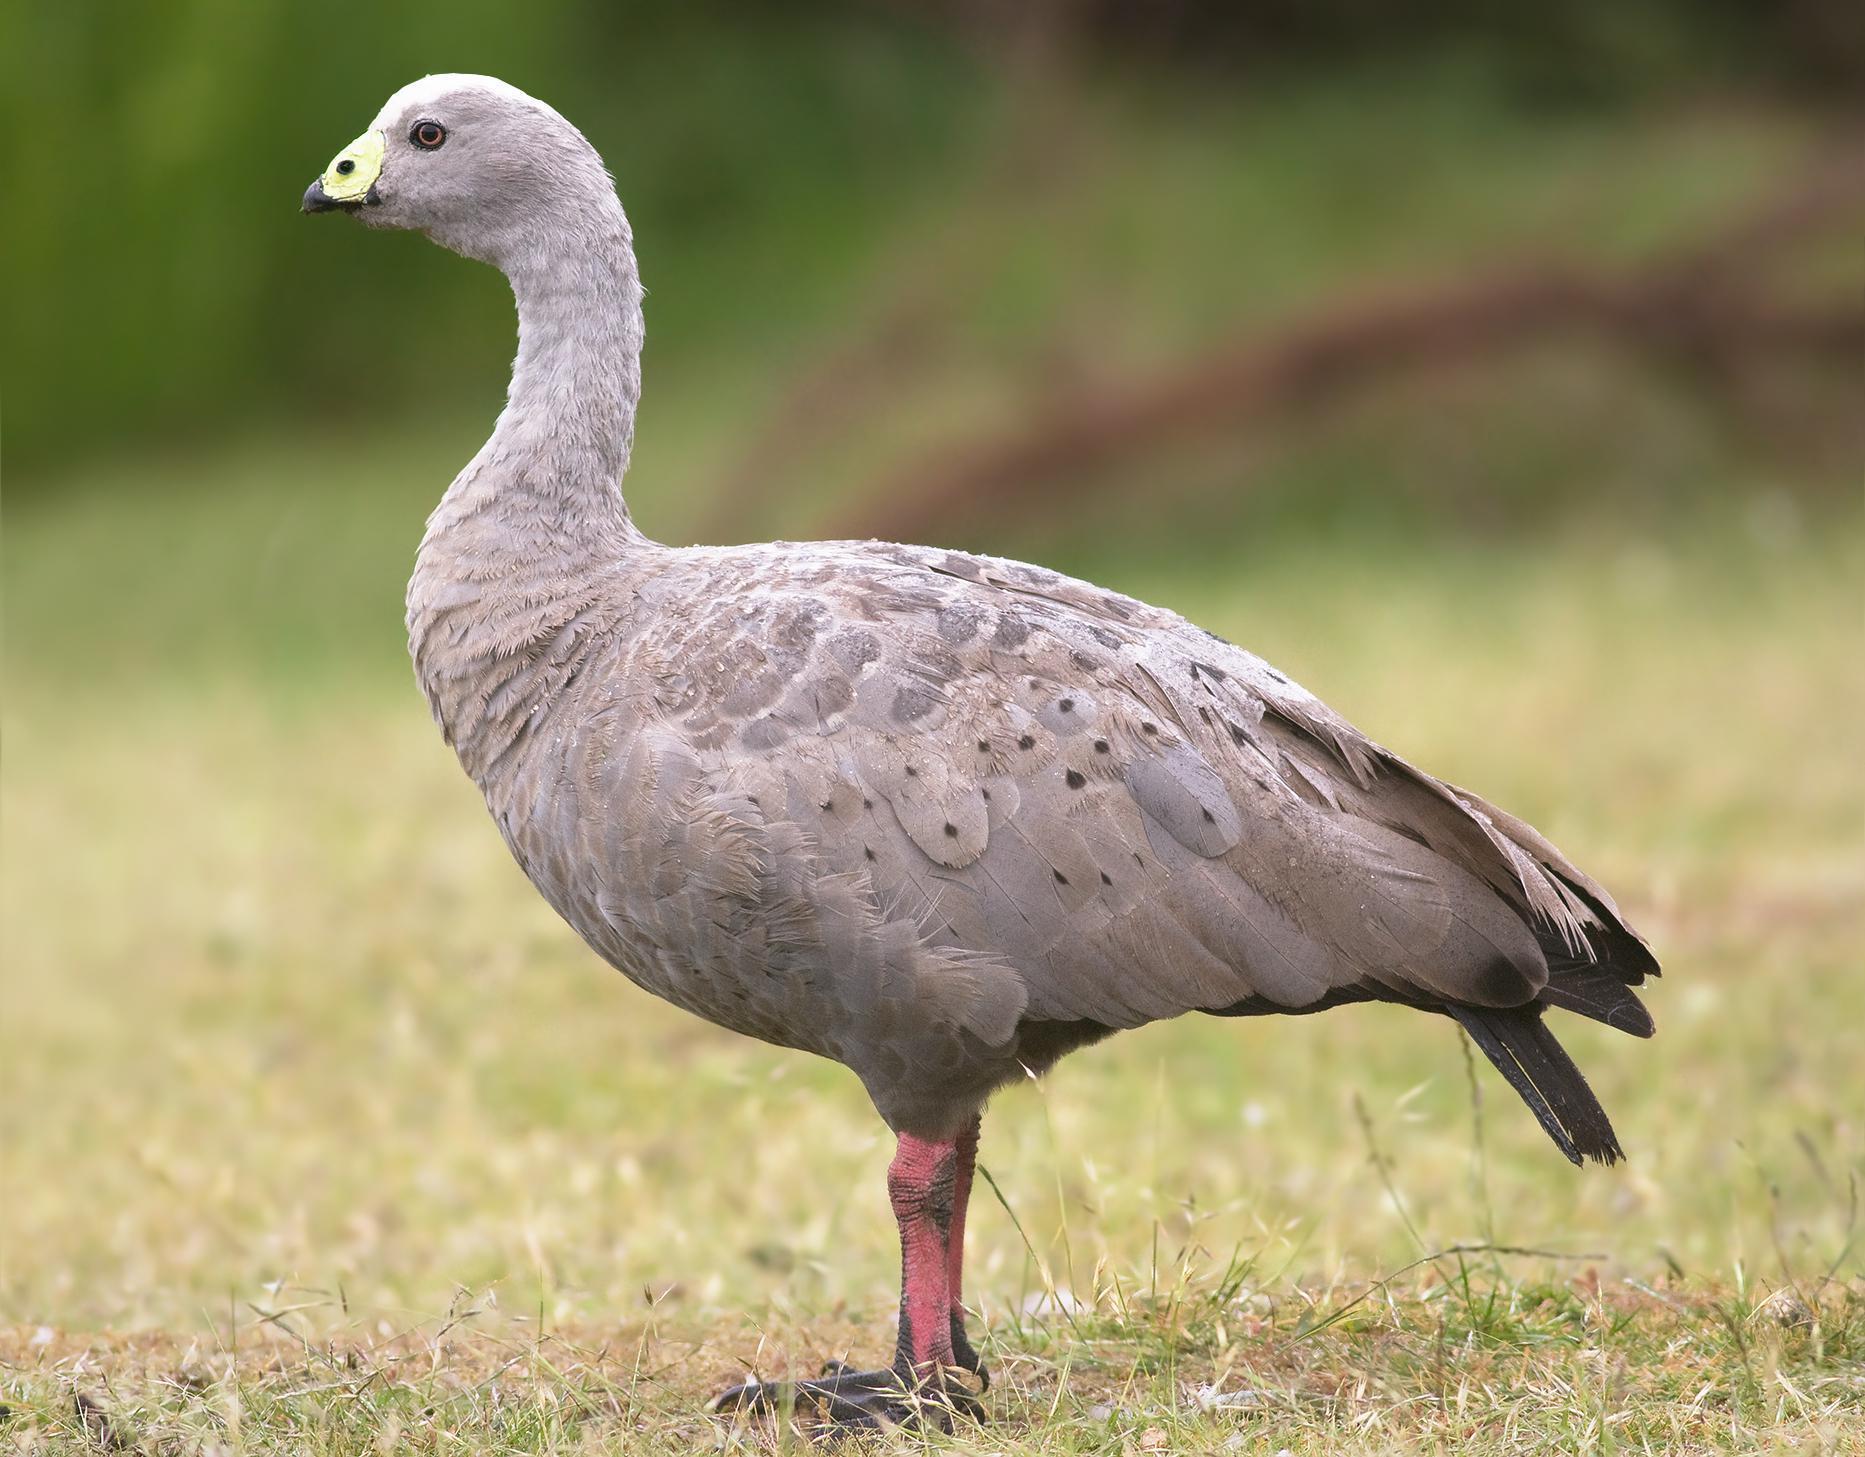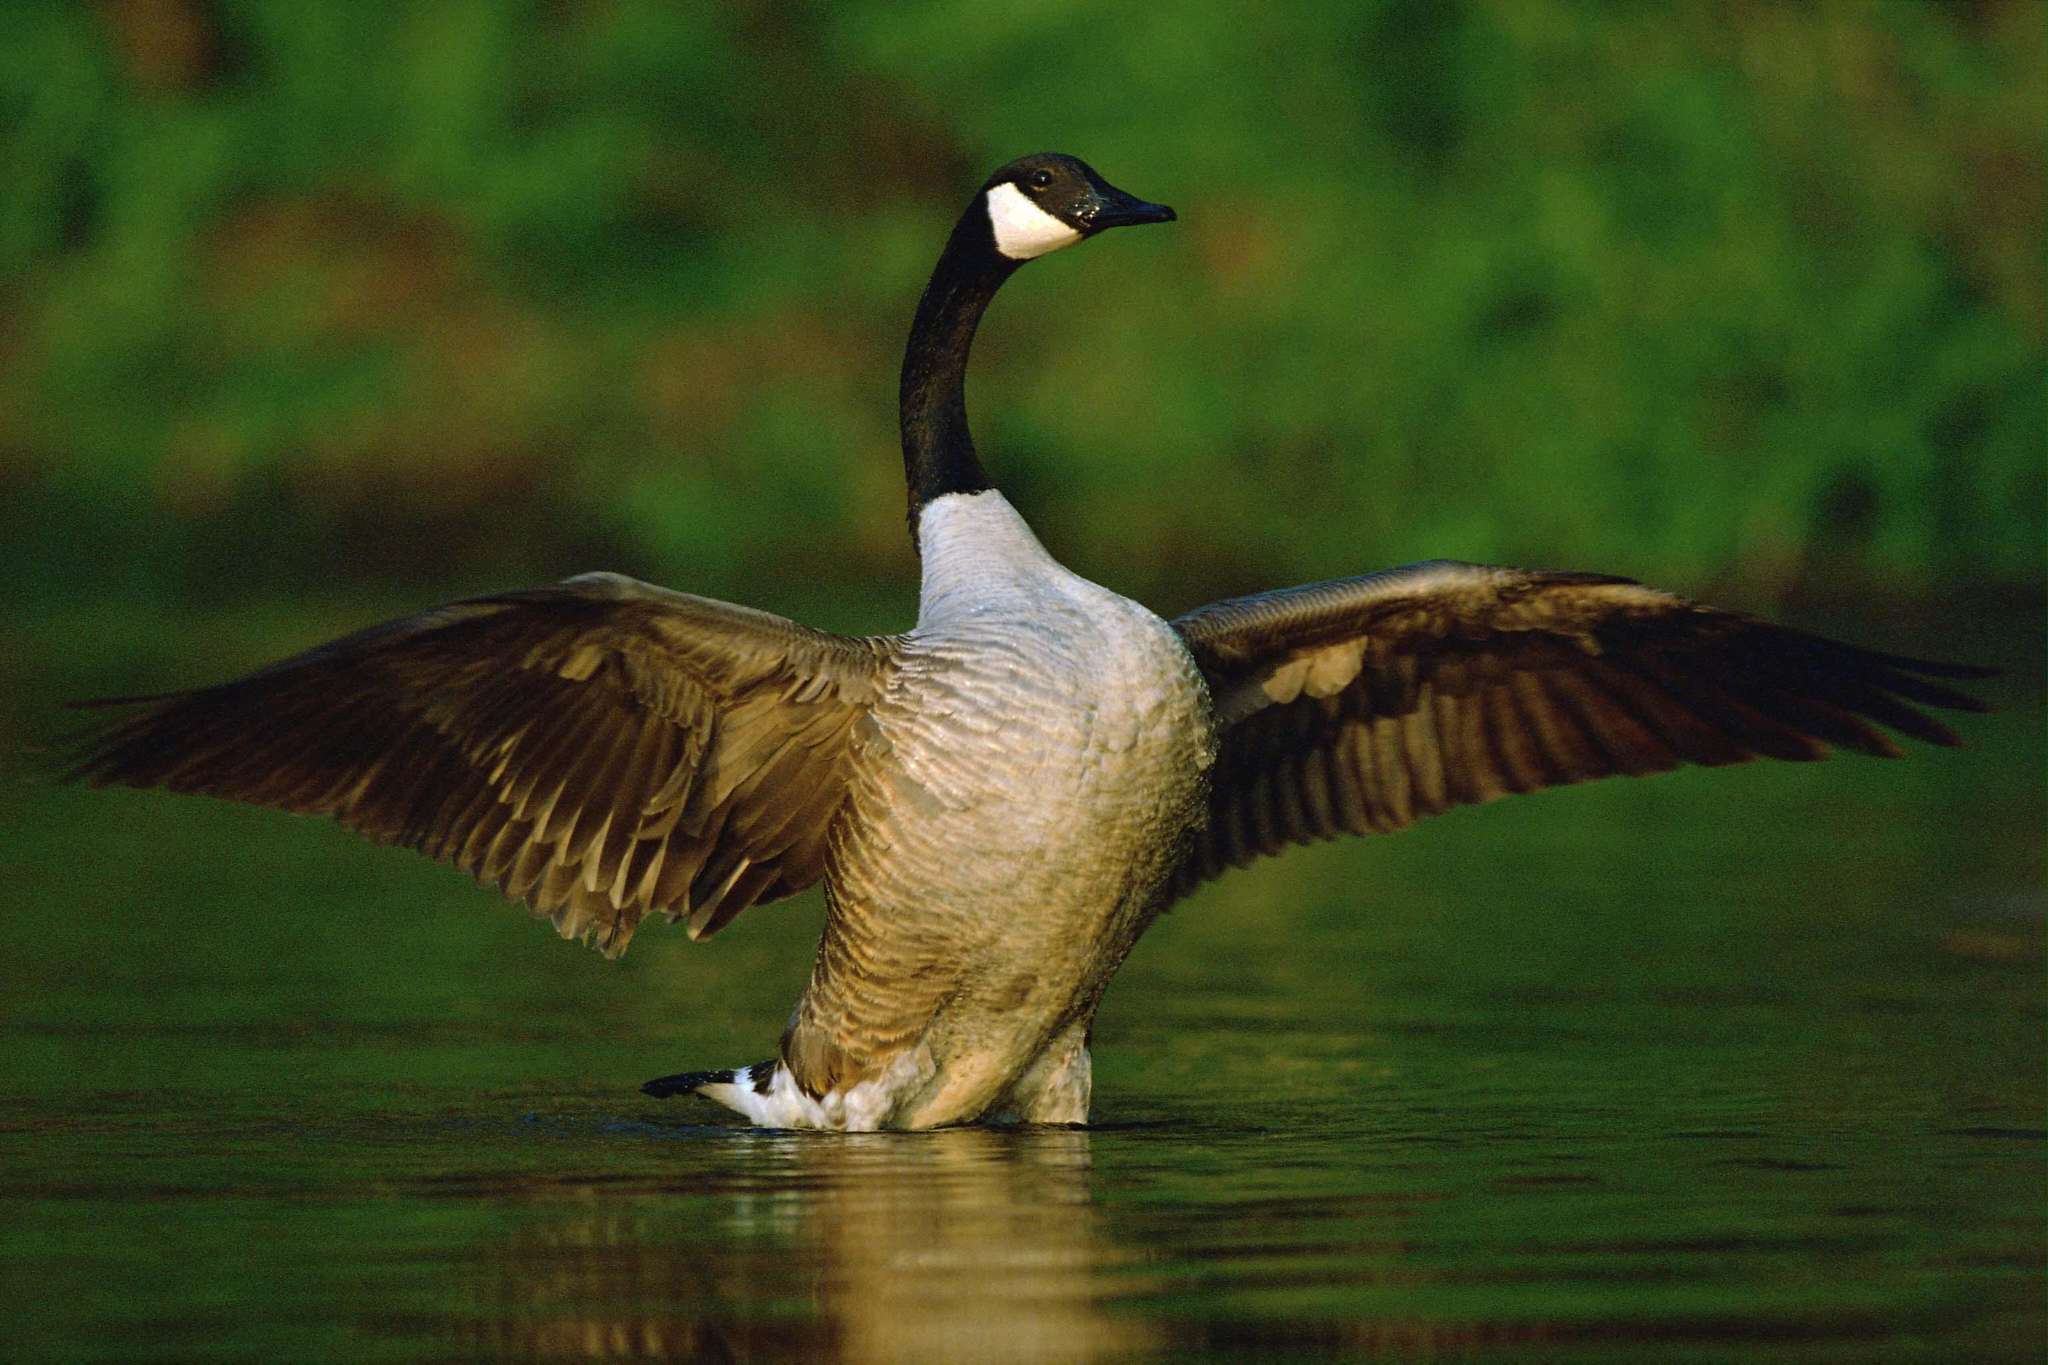The first image is the image on the left, the second image is the image on the right. For the images shown, is this caption "In one of the images, a goose is flapping its wings while on the water" true? Answer yes or no. Yes. 